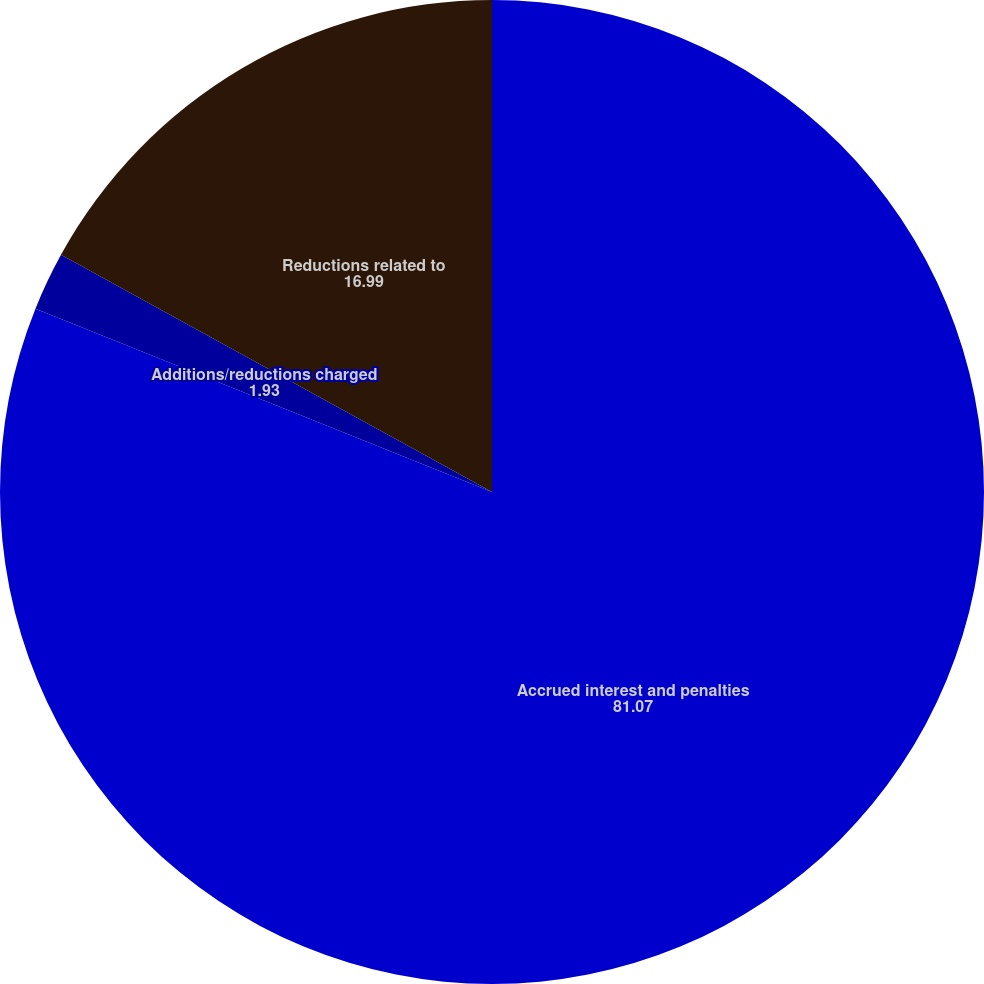Convert chart. <chart><loc_0><loc_0><loc_500><loc_500><pie_chart><fcel>Accrued interest and penalties<fcel>Additions/reductions charged<fcel>Reductions related to<nl><fcel>81.07%<fcel>1.93%<fcel>16.99%<nl></chart> 